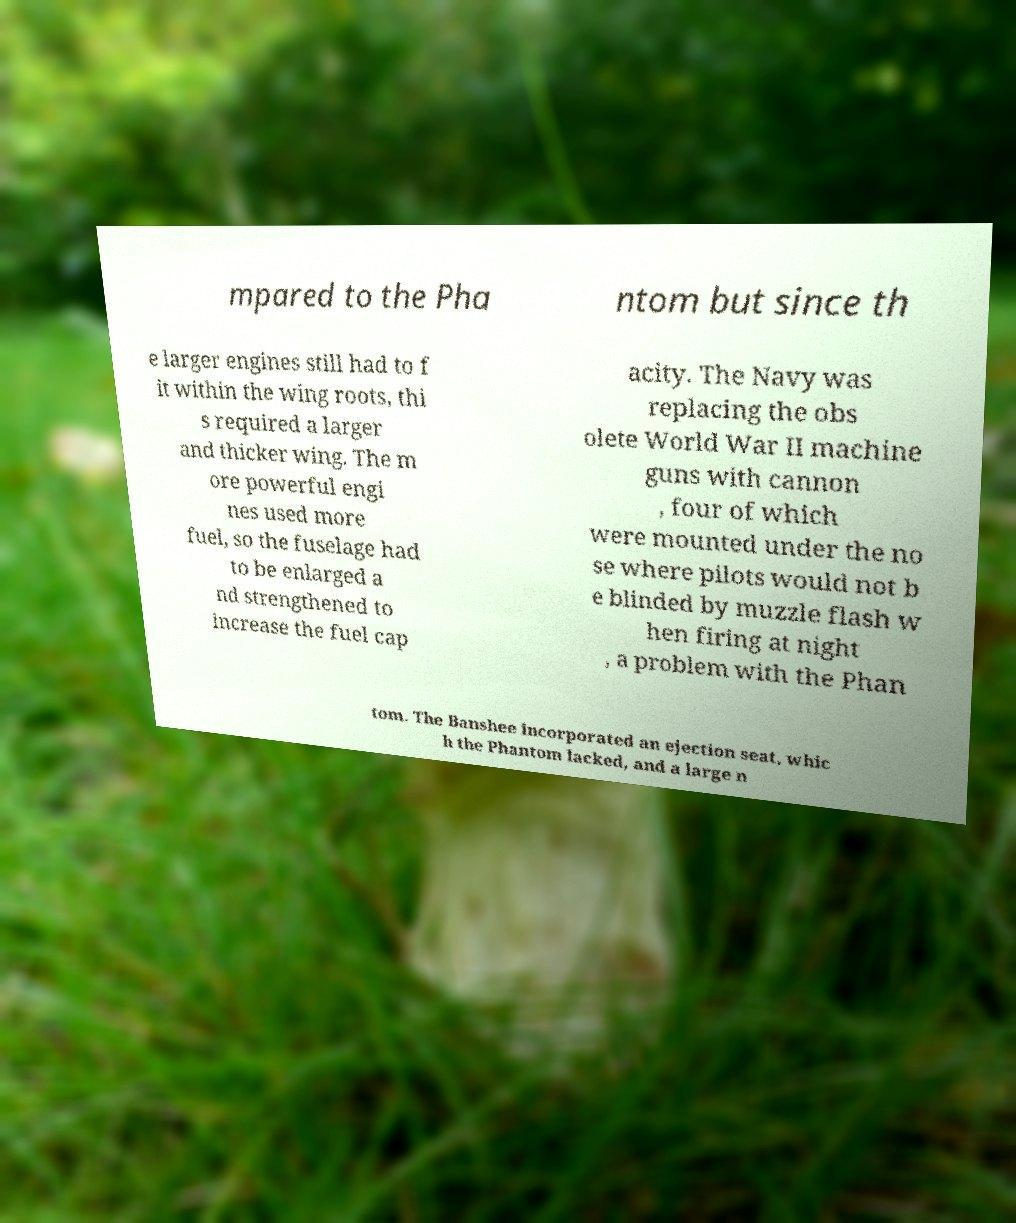I need the written content from this picture converted into text. Can you do that? mpared to the Pha ntom but since th e larger engines still had to f it within the wing roots, thi s required a larger and thicker wing. The m ore powerful engi nes used more fuel, so the fuselage had to be enlarged a nd strengthened to increase the fuel cap acity. The Navy was replacing the obs olete World War II machine guns with cannon , four of which were mounted under the no se where pilots would not b e blinded by muzzle flash w hen firing at night , a problem with the Phan tom. The Banshee incorporated an ejection seat, whic h the Phantom lacked, and a large n 